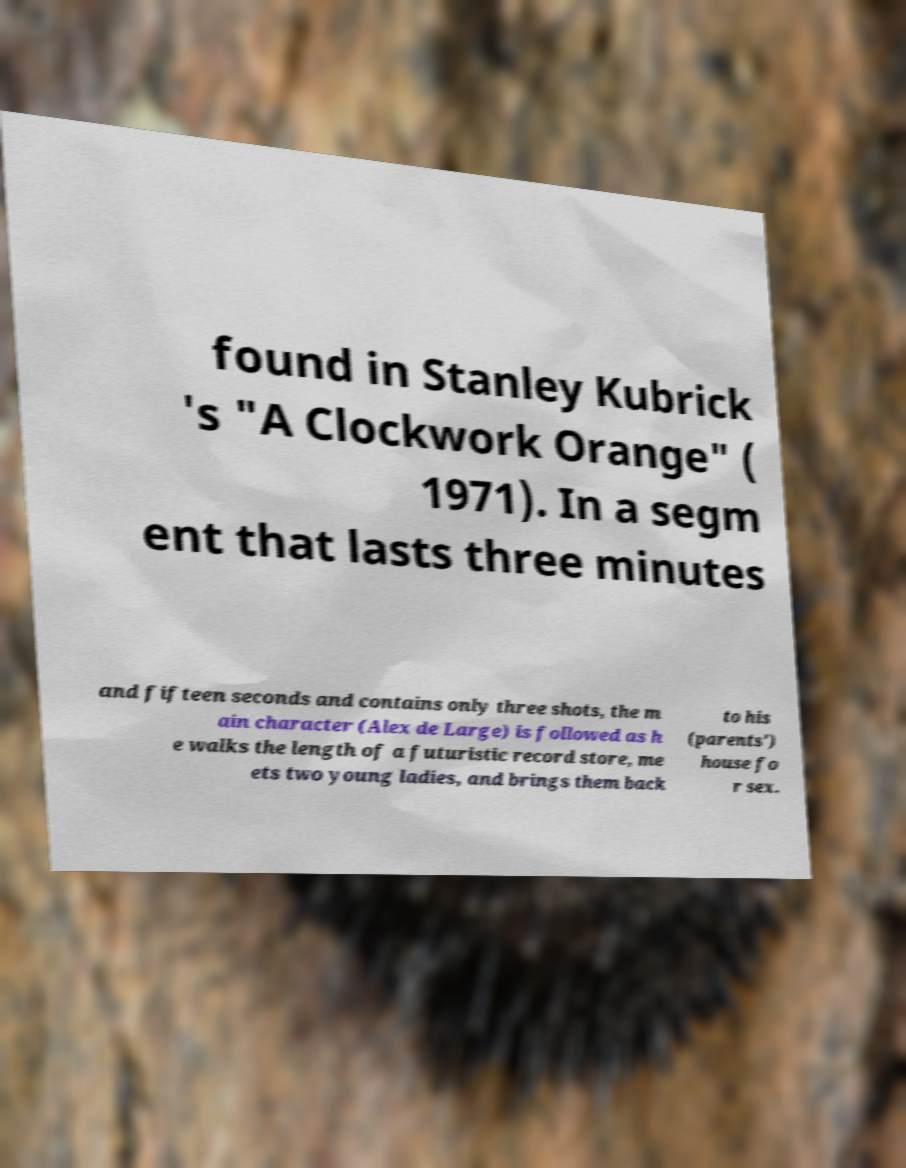Can you accurately transcribe the text from the provided image for me? found in Stanley Kubrick 's "A Clockwork Orange" ( 1971). In a segm ent that lasts three minutes and fifteen seconds and contains only three shots, the m ain character (Alex de Large) is followed as h e walks the length of a futuristic record store, me ets two young ladies, and brings them back to his (parents') house fo r sex. 